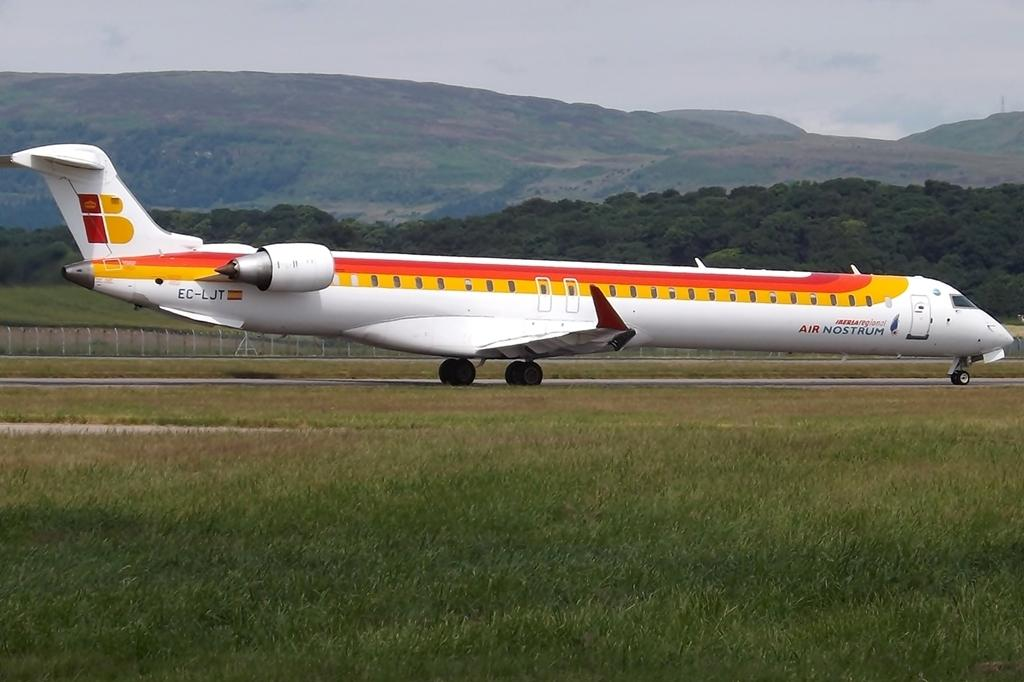<image>
Share a concise interpretation of the image provided. An Air Nostrum airplane on a runway with mountains in the background. 